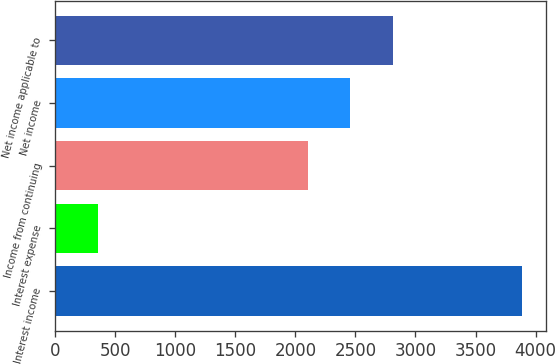Convert chart to OTSL. <chart><loc_0><loc_0><loc_500><loc_500><bar_chart><fcel>Interest income<fcel>Interest expense<fcel>Income from continuing<fcel>Net income<fcel>Net income applicable to<nl><fcel>3888<fcel>359<fcel>2104<fcel>2456.9<fcel>2809.8<nl></chart> 